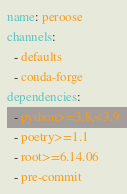<code> <loc_0><loc_0><loc_500><loc_500><_YAML_>name: peroose
channels:
  - defaults
  - conda-forge
dependencies:
  - python>=3.8,<3.9
  - poetry>=1.1
  - root>=6.14.06
  - pre-commit</code> 